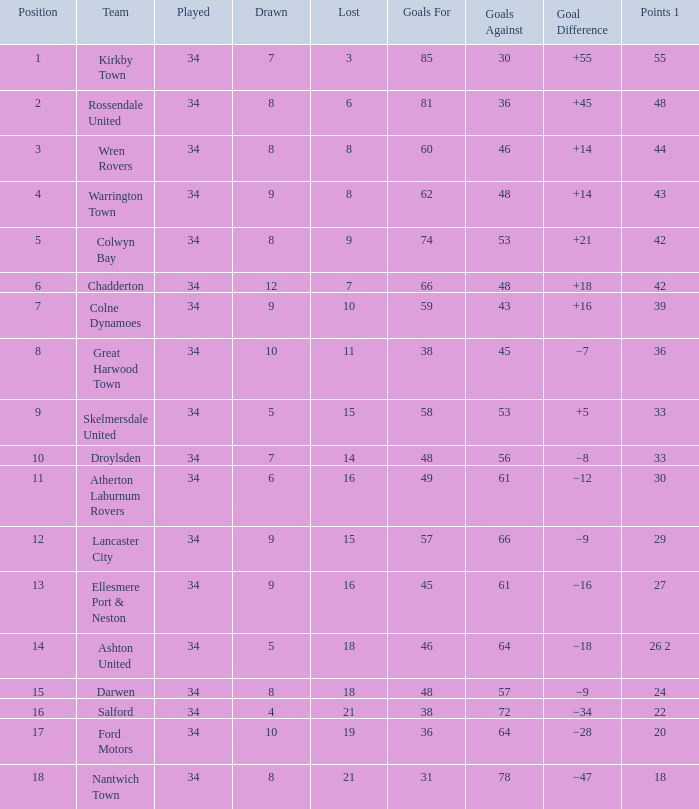What is the smallest number of goals against when 8 games were lost, and the goals for are 60? 46.0. 